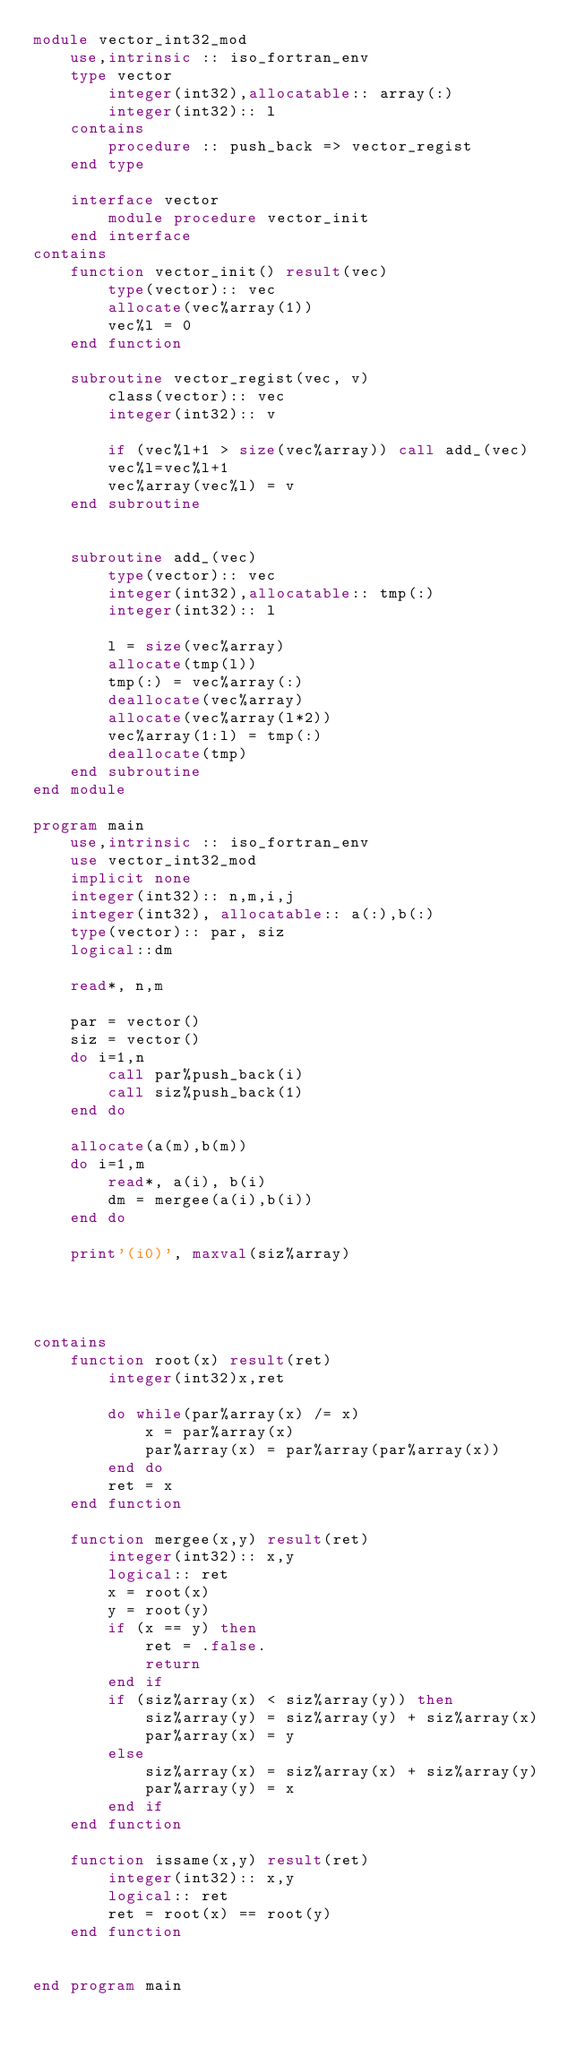<code> <loc_0><loc_0><loc_500><loc_500><_FORTRAN_>module vector_int32_mod
    use,intrinsic :: iso_fortran_env
    type vector
        integer(int32),allocatable:: array(:)
        integer(int32):: l
    contains
        procedure :: push_back => vector_regist
    end type

    interface vector
        module procedure vector_init
    end interface
contains
    function vector_init() result(vec)
        type(vector):: vec
        allocate(vec%array(1))
        vec%l = 0
    end function

    subroutine vector_regist(vec, v)
        class(vector):: vec
        integer(int32):: v

        if (vec%l+1 > size(vec%array)) call add_(vec)
        vec%l=vec%l+1
        vec%array(vec%l) = v
    end subroutine


    subroutine add_(vec)
        type(vector):: vec
        integer(int32),allocatable:: tmp(:)
        integer(int32):: l

        l = size(vec%array)
        allocate(tmp(l))
        tmp(:) = vec%array(:)
        deallocate(vec%array)
        allocate(vec%array(l*2))
        vec%array(1:l) = tmp(:)
        deallocate(tmp)
    end subroutine
end module

program main
    use,intrinsic :: iso_fortran_env
    use vector_int32_mod
    implicit none
    integer(int32):: n,m,i,j
    integer(int32), allocatable:: a(:),b(:)
    type(vector):: par, siz
    logical::dm

    read*, n,m

    par = vector()
    siz = vector()
    do i=1,n
        call par%push_back(i)
        call siz%push_back(1)
    end do

    allocate(a(m),b(m))
    do i=1,m
        read*, a(i), b(i)
        dm = mergee(a(i),b(i))
    end do

    print'(i0)', maxval(siz%array)




contains
    function root(x) result(ret)
        integer(int32)x,ret

        do while(par%array(x) /= x)
            x = par%array(x)
            par%array(x) = par%array(par%array(x))
        end do
        ret = x
    end function

    function mergee(x,y) result(ret)
        integer(int32):: x,y
        logical:: ret
        x = root(x)
        y = root(y)
        if (x == y) then
            ret = .false.
            return
        end if
        if (siz%array(x) < siz%array(y)) then
            siz%array(y) = siz%array(y) + siz%array(x)
            par%array(x) = y
        else
            siz%array(x) = siz%array(x) + siz%array(y)
            par%array(y) = x
        end if
    end function

    function issame(x,y) result(ret)
        integer(int32):: x,y
        logical:: ret
        ret = root(x) == root(y)
    end function

    
end program main</code> 